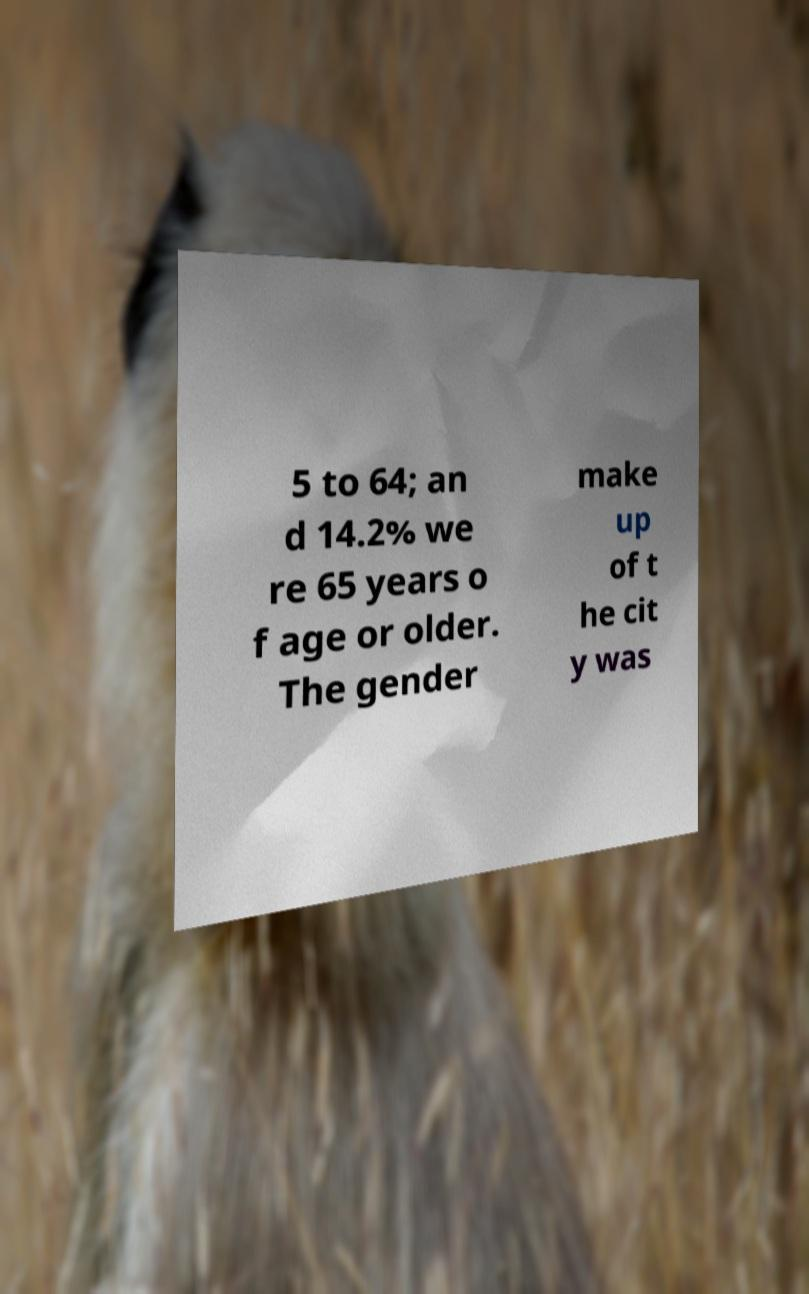Please read and relay the text visible in this image. What does it say? 5 to 64; an d 14.2% we re 65 years o f age or older. The gender make up of t he cit y was 